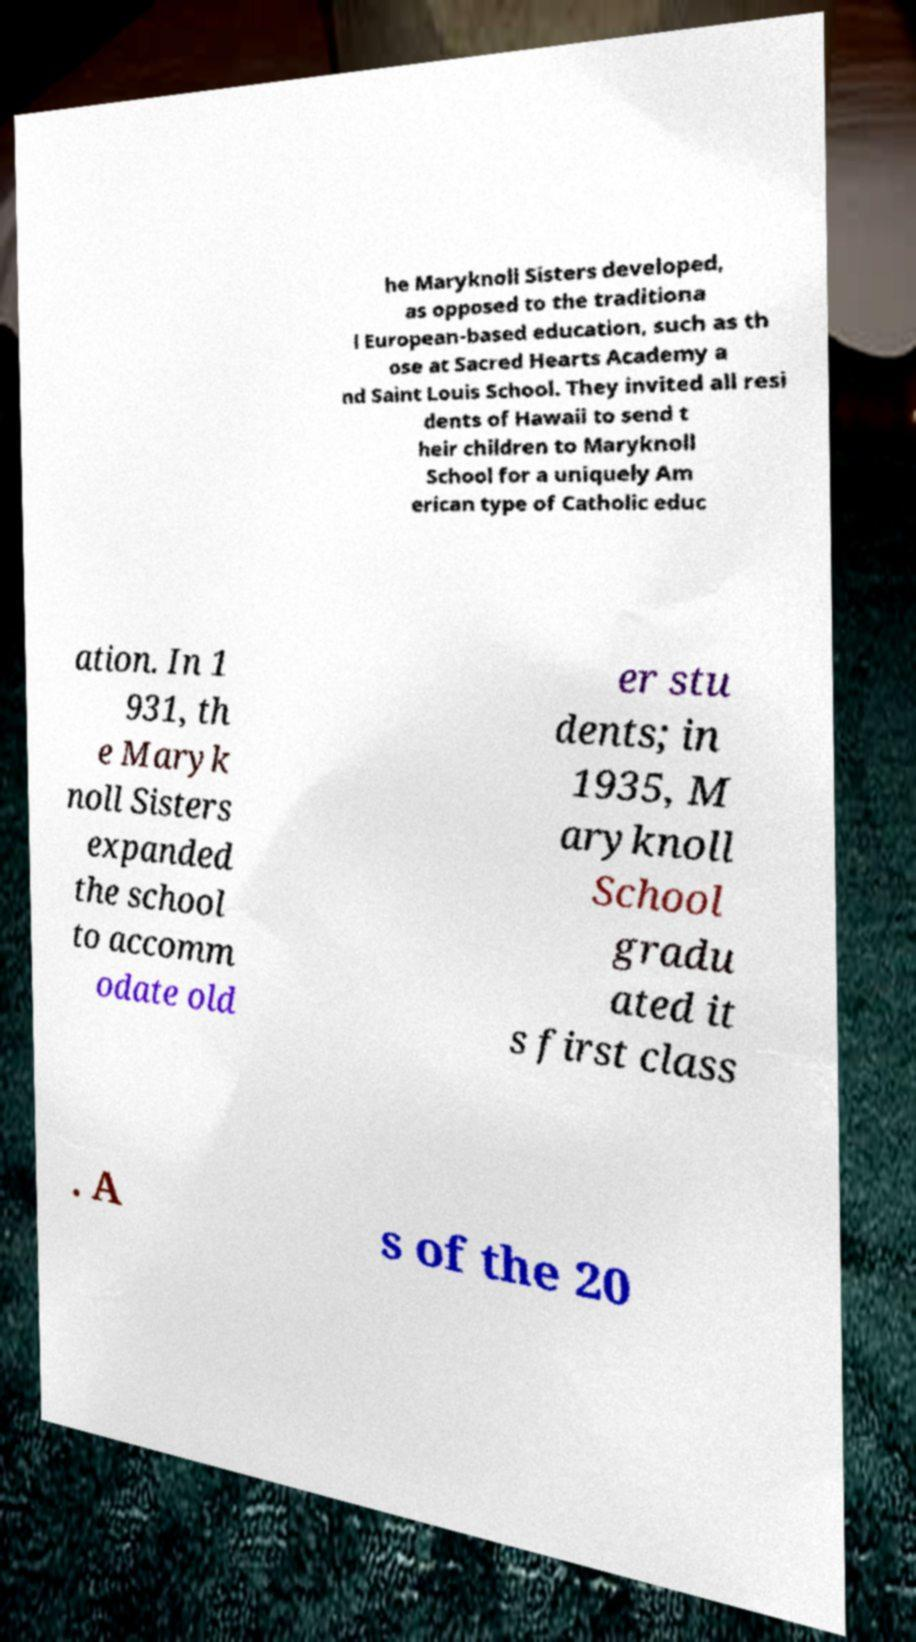Can you read and provide the text displayed in the image?This photo seems to have some interesting text. Can you extract and type it out for me? he Maryknoll Sisters developed, as opposed to the traditiona l European-based education, such as th ose at Sacred Hearts Academy a nd Saint Louis School. They invited all resi dents of Hawaii to send t heir children to Maryknoll School for a uniquely Am erican type of Catholic educ ation. In 1 931, th e Maryk noll Sisters expanded the school to accomm odate old er stu dents; in 1935, M aryknoll School gradu ated it s first class . A s of the 20 